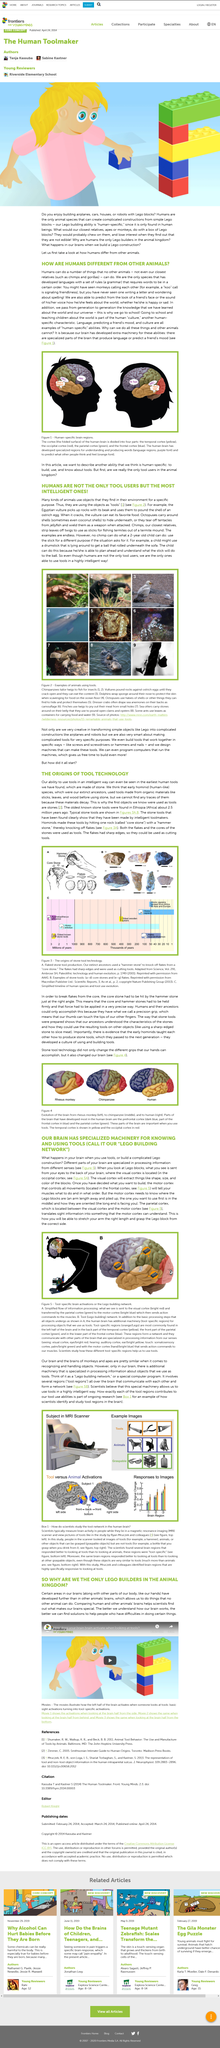Give some essential details in this illustration. Figure 1 illustrates the human-specific brain regions that are associated with semantic processing. Humans are the only animal species known to be capable of constructing complex structures using simple Lego blocks. In the image, two types of stones are depicted: a hammer stone and a core stone. I recently saved a video in my watch later queue and am inquiring about the specific video, as well as contemplating the cognitive processes that are activated when viewing tools. The parietal cortex is located in the middle, between the visual and motor cortices. 